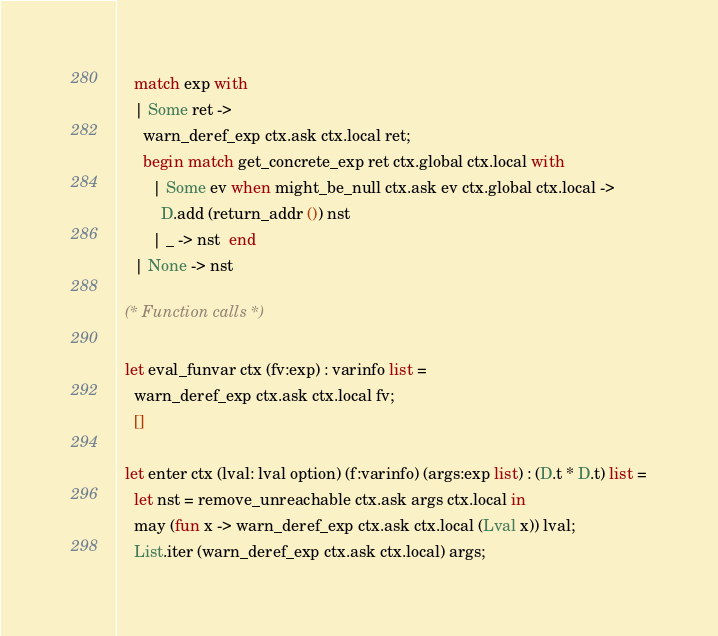Convert code to text. <code><loc_0><loc_0><loc_500><loc_500><_OCaml_>    match exp with
    | Some ret ->
      warn_deref_exp ctx.ask ctx.local ret;
      begin match get_concrete_exp ret ctx.global ctx.local with
        | Some ev when might_be_null ctx.ask ev ctx.global ctx.local ->
          D.add (return_addr ()) nst
        | _ -> nst  end
    | None -> nst

  (* Function calls *)

  let eval_funvar ctx (fv:exp) : varinfo list =
    warn_deref_exp ctx.ask ctx.local fv;
    []

  let enter ctx (lval: lval option) (f:varinfo) (args:exp list) : (D.t * D.t) list =
    let nst = remove_unreachable ctx.ask args ctx.local in
    may (fun x -> warn_deref_exp ctx.ask ctx.local (Lval x)) lval;
    List.iter (warn_deref_exp ctx.ask ctx.local) args;</code> 